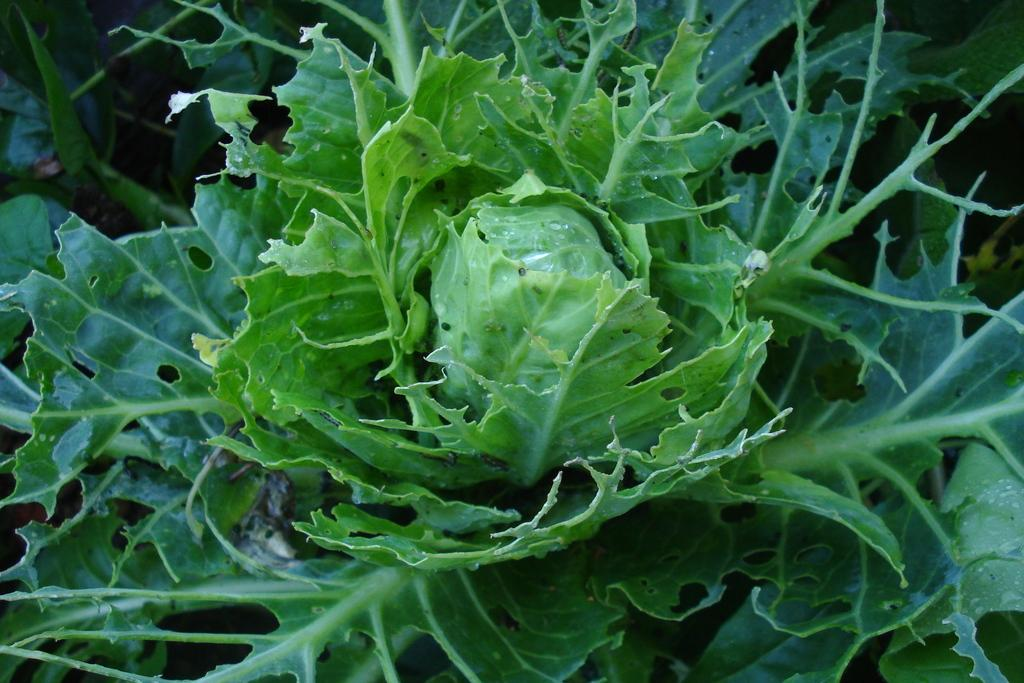What is present in the image? There is a plant in the image. Can you hear the plant laughing in the image? There is no indication of laughter or sound in the image, as it features a plant and plants do not have the ability to laugh. 